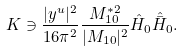<formula> <loc_0><loc_0><loc_500><loc_500>K \ni \frac { | y ^ { u } | ^ { 2 } } { 1 6 \pi ^ { 2 } } \frac { M _ { 1 0 } ^ { * 2 } } { | M _ { 1 0 } | ^ { 2 } } \hat { H } _ { 0 } \hat { \bar { H } } _ { 0 } .</formula> 